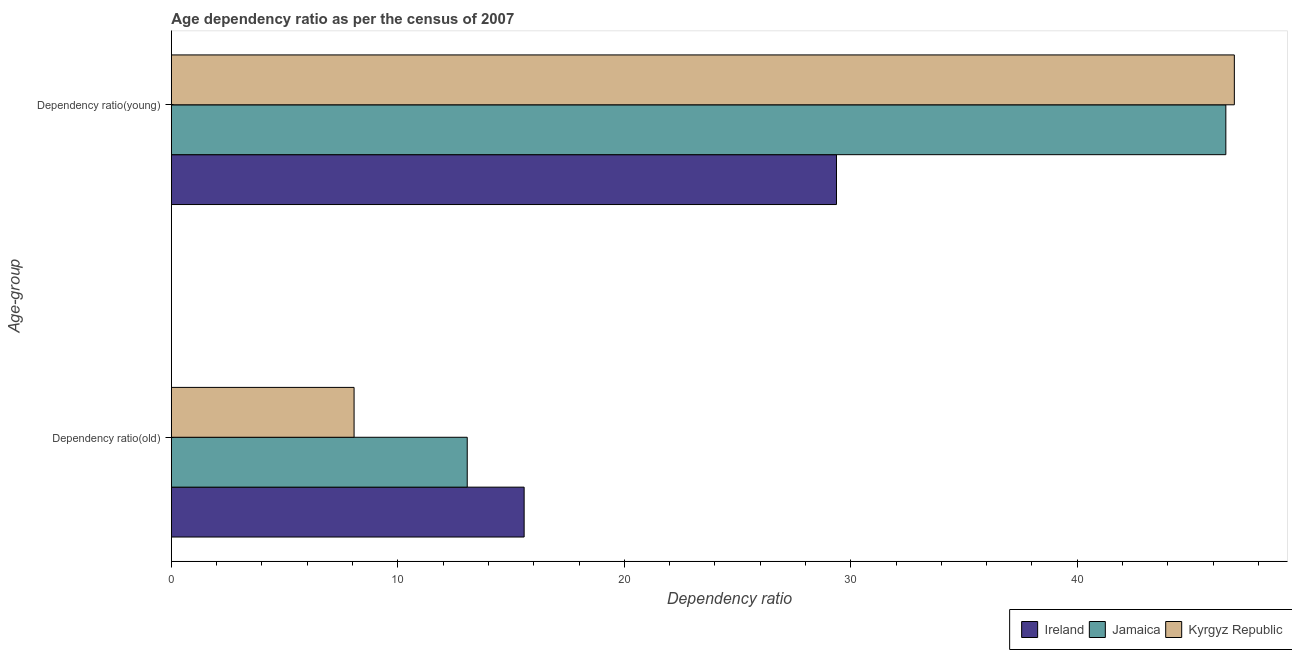How many different coloured bars are there?
Your response must be concise. 3. How many groups of bars are there?
Ensure brevity in your answer.  2. Are the number of bars per tick equal to the number of legend labels?
Give a very brief answer. Yes. How many bars are there on the 1st tick from the top?
Make the answer very short. 3. How many bars are there on the 1st tick from the bottom?
Provide a short and direct response. 3. What is the label of the 2nd group of bars from the top?
Your answer should be compact. Dependency ratio(old). What is the age dependency ratio(old) in Ireland?
Provide a succinct answer. 15.58. Across all countries, what is the maximum age dependency ratio(old)?
Offer a very short reply. 15.58. Across all countries, what is the minimum age dependency ratio(young)?
Your answer should be compact. 29.37. In which country was the age dependency ratio(young) maximum?
Give a very brief answer. Kyrgyz Republic. In which country was the age dependency ratio(old) minimum?
Make the answer very short. Kyrgyz Republic. What is the total age dependency ratio(old) in the graph?
Provide a succinct answer. 36.71. What is the difference between the age dependency ratio(old) in Kyrgyz Republic and that in Ireland?
Your answer should be very brief. -7.51. What is the difference between the age dependency ratio(old) in Kyrgyz Republic and the age dependency ratio(young) in Ireland?
Offer a terse response. -21.3. What is the average age dependency ratio(old) per country?
Your answer should be very brief. 12.24. What is the difference between the age dependency ratio(old) and age dependency ratio(young) in Jamaica?
Your answer should be compact. -33.5. What is the ratio of the age dependency ratio(young) in Jamaica to that in Kyrgyz Republic?
Your response must be concise. 0.99. What does the 1st bar from the top in Dependency ratio(old) represents?
Ensure brevity in your answer.  Kyrgyz Republic. What does the 3rd bar from the bottom in Dependency ratio(old) represents?
Give a very brief answer. Kyrgyz Republic. Are all the bars in the graph horizontal?
Your response must be concise. Yes. How many countries are there in the graph?
Provide a succinct answer. 3. What is the difference between two consecutive major ticks on the X-axis?
Your answer should be very brief. 10. Are the values on the major ticks of X-axis written in scientific E-notation?
Keep it short and to the point. No. Does the graph contain any zero values?
Provide a short and direct response. No. Does the graph contain grids?
Provide a short and direct response. No. How many legend labels are there?
Make the answer very short. 3. How are the legend labels stacked?
Keep it short and to the point. Horizontal. What is the title of the graph?
Keep it short and to the point. Age dependency ratio as per the census of 2007. What is the label or title of the X-axis?
Your answer should be compact. Dependency ratio. What is the label or title of the Y-axis?
Your response must be concise. Age-group. What is the Dependency ratio in Ireland in Dependency ratio(old)?
Your answer should be very brief. 15.58. What is the Dependency ratio in Jamaica in Dependency ratio(old)?
Offer a very short reply. 13.06. What is the Dependency ratio of Kyrgyz Republic in Dependency ratio(old)?
Your answer should be very brief. 8.07. What is the Dependency ratio of Ireland in Dependency ratio(young)?
Give a very brief answer. 29.37. What is the Dependency ratio of Jamaica in Dependency ratio(young)?
Provide a succinct answer. 46.56. What is the Dependency ratio of Kyrgyz Republic in Dependency ratio(young)?
Make the answer very short. 46.93. Across all Age-group, what is the maximum Dependency ratio in Ireland?
Ensure brevity in your answer.  29.37. Across all Age-group, what is the maximum Dependency ratio of Jamaica?
Your response must be concise. 46.56. Across all Age-group, what is the maximum Dependency ratio in Kyrgyz Republic?
Your answer should be very brief. 46.93. Across all Age-group, what is the minimum Dependency ratio of Ireland?
Your answer should be compact. 15.58. Across all Age-group, what is the minimum Dependency ratio in Jamaica?
Your response must be concise. 13.06. Across all Age-group, what is the minimum Dependency ratio in Kyrgyz Republic?
Your answer should be compact. 8.07. What is the total Dependency ratio in Ireland in the graph?
Your response must be concise. 44.94. What is the total Dependency ratio of Jamaica in the graph?
Make the answer very short. 59.62. What is the total Dependency ratio of Kyrgyz Republic in the graph?
Keep it short and to the point. 55. What is the difference between the Dependency ratio of Ireland in Dependency ratio(old) and that in Dependency ratio(young)?
Your answer should be compact. -13.79. What is the difference between the Dependency ratio of Jamaica in Dependency ratio(old) and that in Dependency ratio(young)?
Make the answer very short. -33.5. What is the difference between the Dependency ratio in Kyrgyz Republic in Dependency ratio(old) and that in Dependency ratio(young)?
Offer a terse response. -38.87. What is the difference between the Dependency ratio of Ireland in Dependency ratio(old) and the Dependency ratio of Jamaica in Dependency ratio(young)?
Keep it short and to the point. -30.98. What is the difference between the Dependency ratio in Ireland in Dependency ratio(old) and the Dependency ratio in Kyrgyz Republic in Dependency ratio(young)?
Your response must be concise. -31.36. What is the difference between the Dependency ratio of Jamaica in Dependency ratio(old) and the Dependency ratio of Kyrgyz Republic in Dependency ratio(young)?
Ensure brevity in your answer.  -33.87. What is the average Dependency ratio in Ireland per Age-group?
Give a very brief answer. 22.47. What is the average Dependency ratio of Jamaica per Age-group?
Make the answer very short. 29.81. What is the average Dependency ratio of Kyrgyz Republic per Age-group?
Make the answer very short. 27.5. What is the difference between the Dependency ratio of Ireland and Dependency ratio of Jamaica in Dependency ratio(old)?
Provide a short and direct response. 2.51. What is the difference between the Dependency ratio of Ireland and Dependency ratio of Kyrgyz Republic in Dependency ratio(old)?
Offer a terse response. 7.51. What is the difference between the Dependency ratio of Jamaica and Dependency ratio of Kyrgyz Republic in Dependency ratio(old)?
Make the answer very short. 5. What is the difference between the Dependency ratio in Ireland and Dependency ratio in Jamaica in Dependency ratio(young)?
Your answer should be compact. -17.19. What is the difference between the Dependency ratio of Ireland and Dependency ratio of Kyrgyz Republic in Dependency ratio(young)?
Give a very brief answer. -17.57. What is the difference between the Dependency ratio in Jamaica and Dependency ratio in Kyrgyz Republic in Dependency ratio(young)?
Make the answer very short. -0.38. What is the ratio of the Dependency ratio in Ireland in Dependency ratio(old) to that in Dependency ratio(young)?
Provide a succinct answer. 0.53. What is the ratio of the Dependency ratio in Jamaica in Dependency ratio(old) to that in Dependency ratio(young)?
Your answer should be very brief. 0.28. What is the ratio of the Dependency ratio of Kyrgyz Republic in Dependency ratio(old) to that in Dependency ratio(young)?
Provide a succinct answer. 0.17. What is the difference between the highest and the second highest Dependency ratio of Ireland?
Your response must be concise. 13.79. What is the difference between the highest and the second highest Dependency ratio of Jamaica?
Your response must be concise. 33.5. What is the difference between the highest and the second highest Dependency ratio in Kyrgyz Republic?
Keep it short and to the point. 38.87. What is the difference between the highest and the lowest Dependency ratio of Ireland?
Your response must be concise. 13.79. What is the difference between the highest and the lowest Dependency ratio in Jamaica?
Provide a succinct answer. 33.5. What is the difference between the highest and the lowest Dependency ratio in Kyrgyz Republic?
Offer a very short reply. 38.87. 